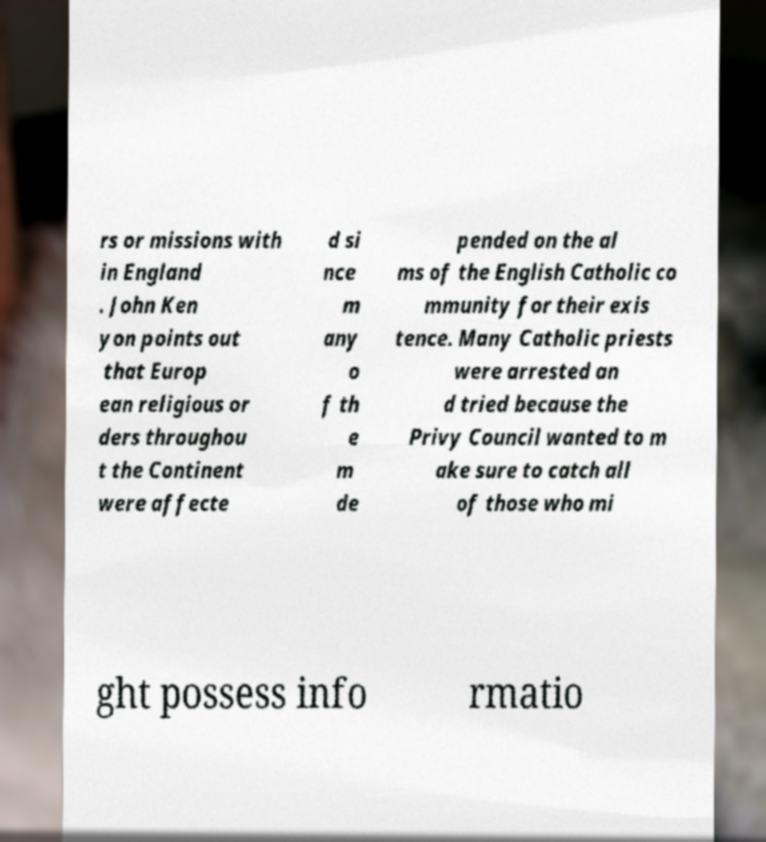Can you accurately transcribe the text from the provided image for me? rs or missions with in England . John Ken yon points out that Europ ean religious or ders throughou t the Continent were affecte d si nce m any o f th e m de pended on the al ms of the English Catholic co mmunity for their exis tence. Many Catholic priests were arrested an d tried because the Privy Council wanted to m ake sure to catch all of those who mi ght possess info rmatio 